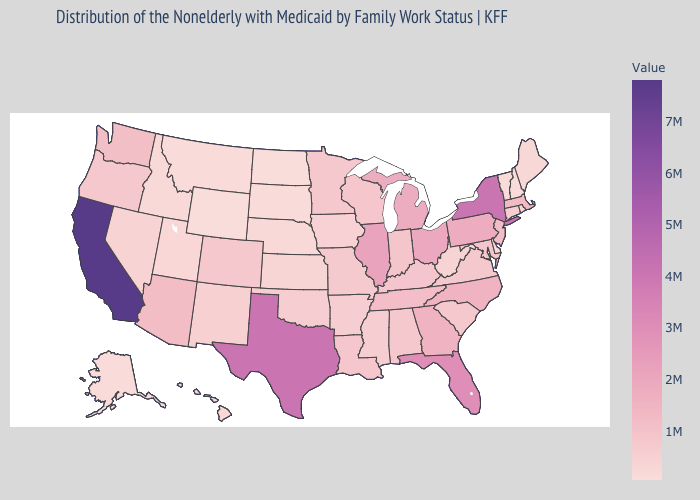Which states have the highest value in the USA?
Answer briefly. California. Which states have the lowest value in the MidWest?
Short answer required. North Dakota. Does Florida have the highest value in the USA?
Short answer required. No. Among the states that border Alabama , which have the highest value?
Keep it brief. Florida. Which states have the highest value in the USA?
Short answer required. California. Which states hav the highest value in the MidWest?
Concise answer only. Illinois. Does Iowa have the highest value in the MidWest?
Keep it brief. No. 